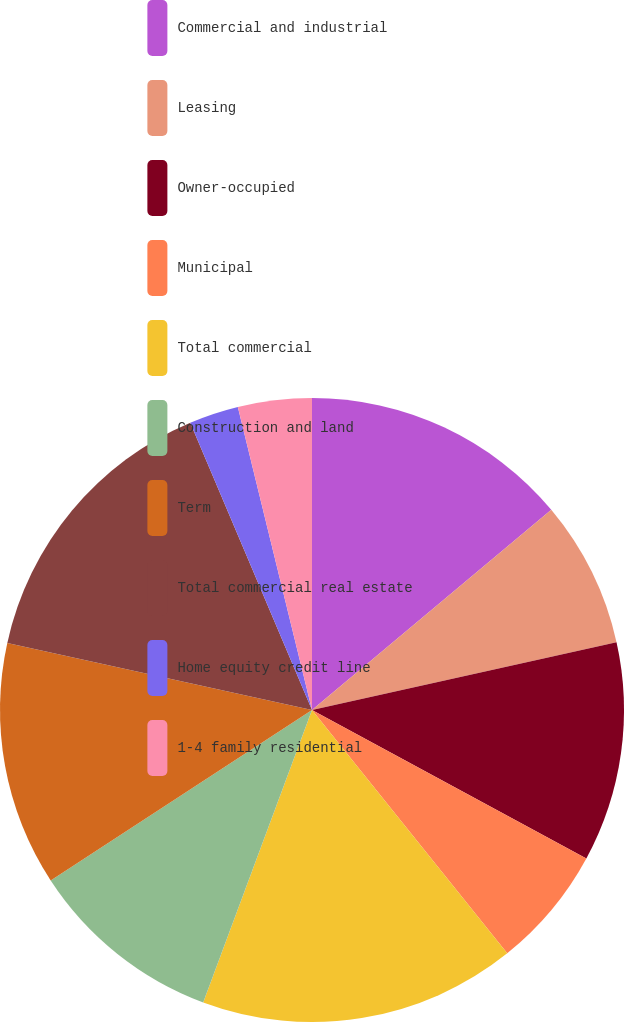Convert chart. <chart><loc_0><loc_0><loc_500><loc_500><pie_chart><fcel>Commercial and industrial<fcel>Leasing<fcel>Owner-occupied<fcel>Municipal<fcel>Total commercial<fcel>Construction and land<fcel>Term<fcel>Total commercial real estate<fcel>Home equity credit line<fcel>1-4 family residential<nl><fcel>13.91%<fcel>7.6%<fcel>11.39%<fcel>6.34%<fcel>16.43%<fcel>10.13%<fcel>12.65%<fcel>15.17%<fcel>2.56%<fcel>3.82%<nl></chart> 